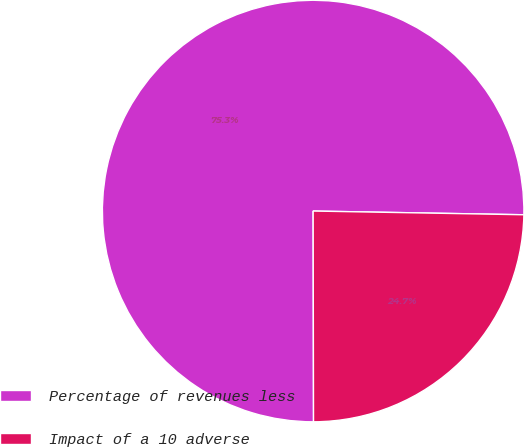Convert chart. <chart><loc_0><loc_0><loc_500><loc_500><pie_chart><fcel>Percentage of revenues less<fcel>Impact of a 10 adverse<nl><fcel>75.31%<fcel>24.69%<nl></chart> 